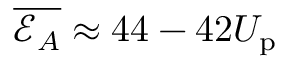<formula> <loc_0><loc_0><loc_500><loc_500>\overline { { \mathcal { E } _ { A } } } \approx 4 4 - 4 2 U _ { p }</formula> 